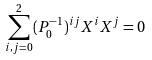<formula> <loc_0><loc_0><loc_500><loc_500>\sum _ { i , j = 0 } ^ { 2 } ( P _ { 0 } ^ { - 1 } ) ^ { i j } X ^ { i } X ^ { j } = 0</formula> 